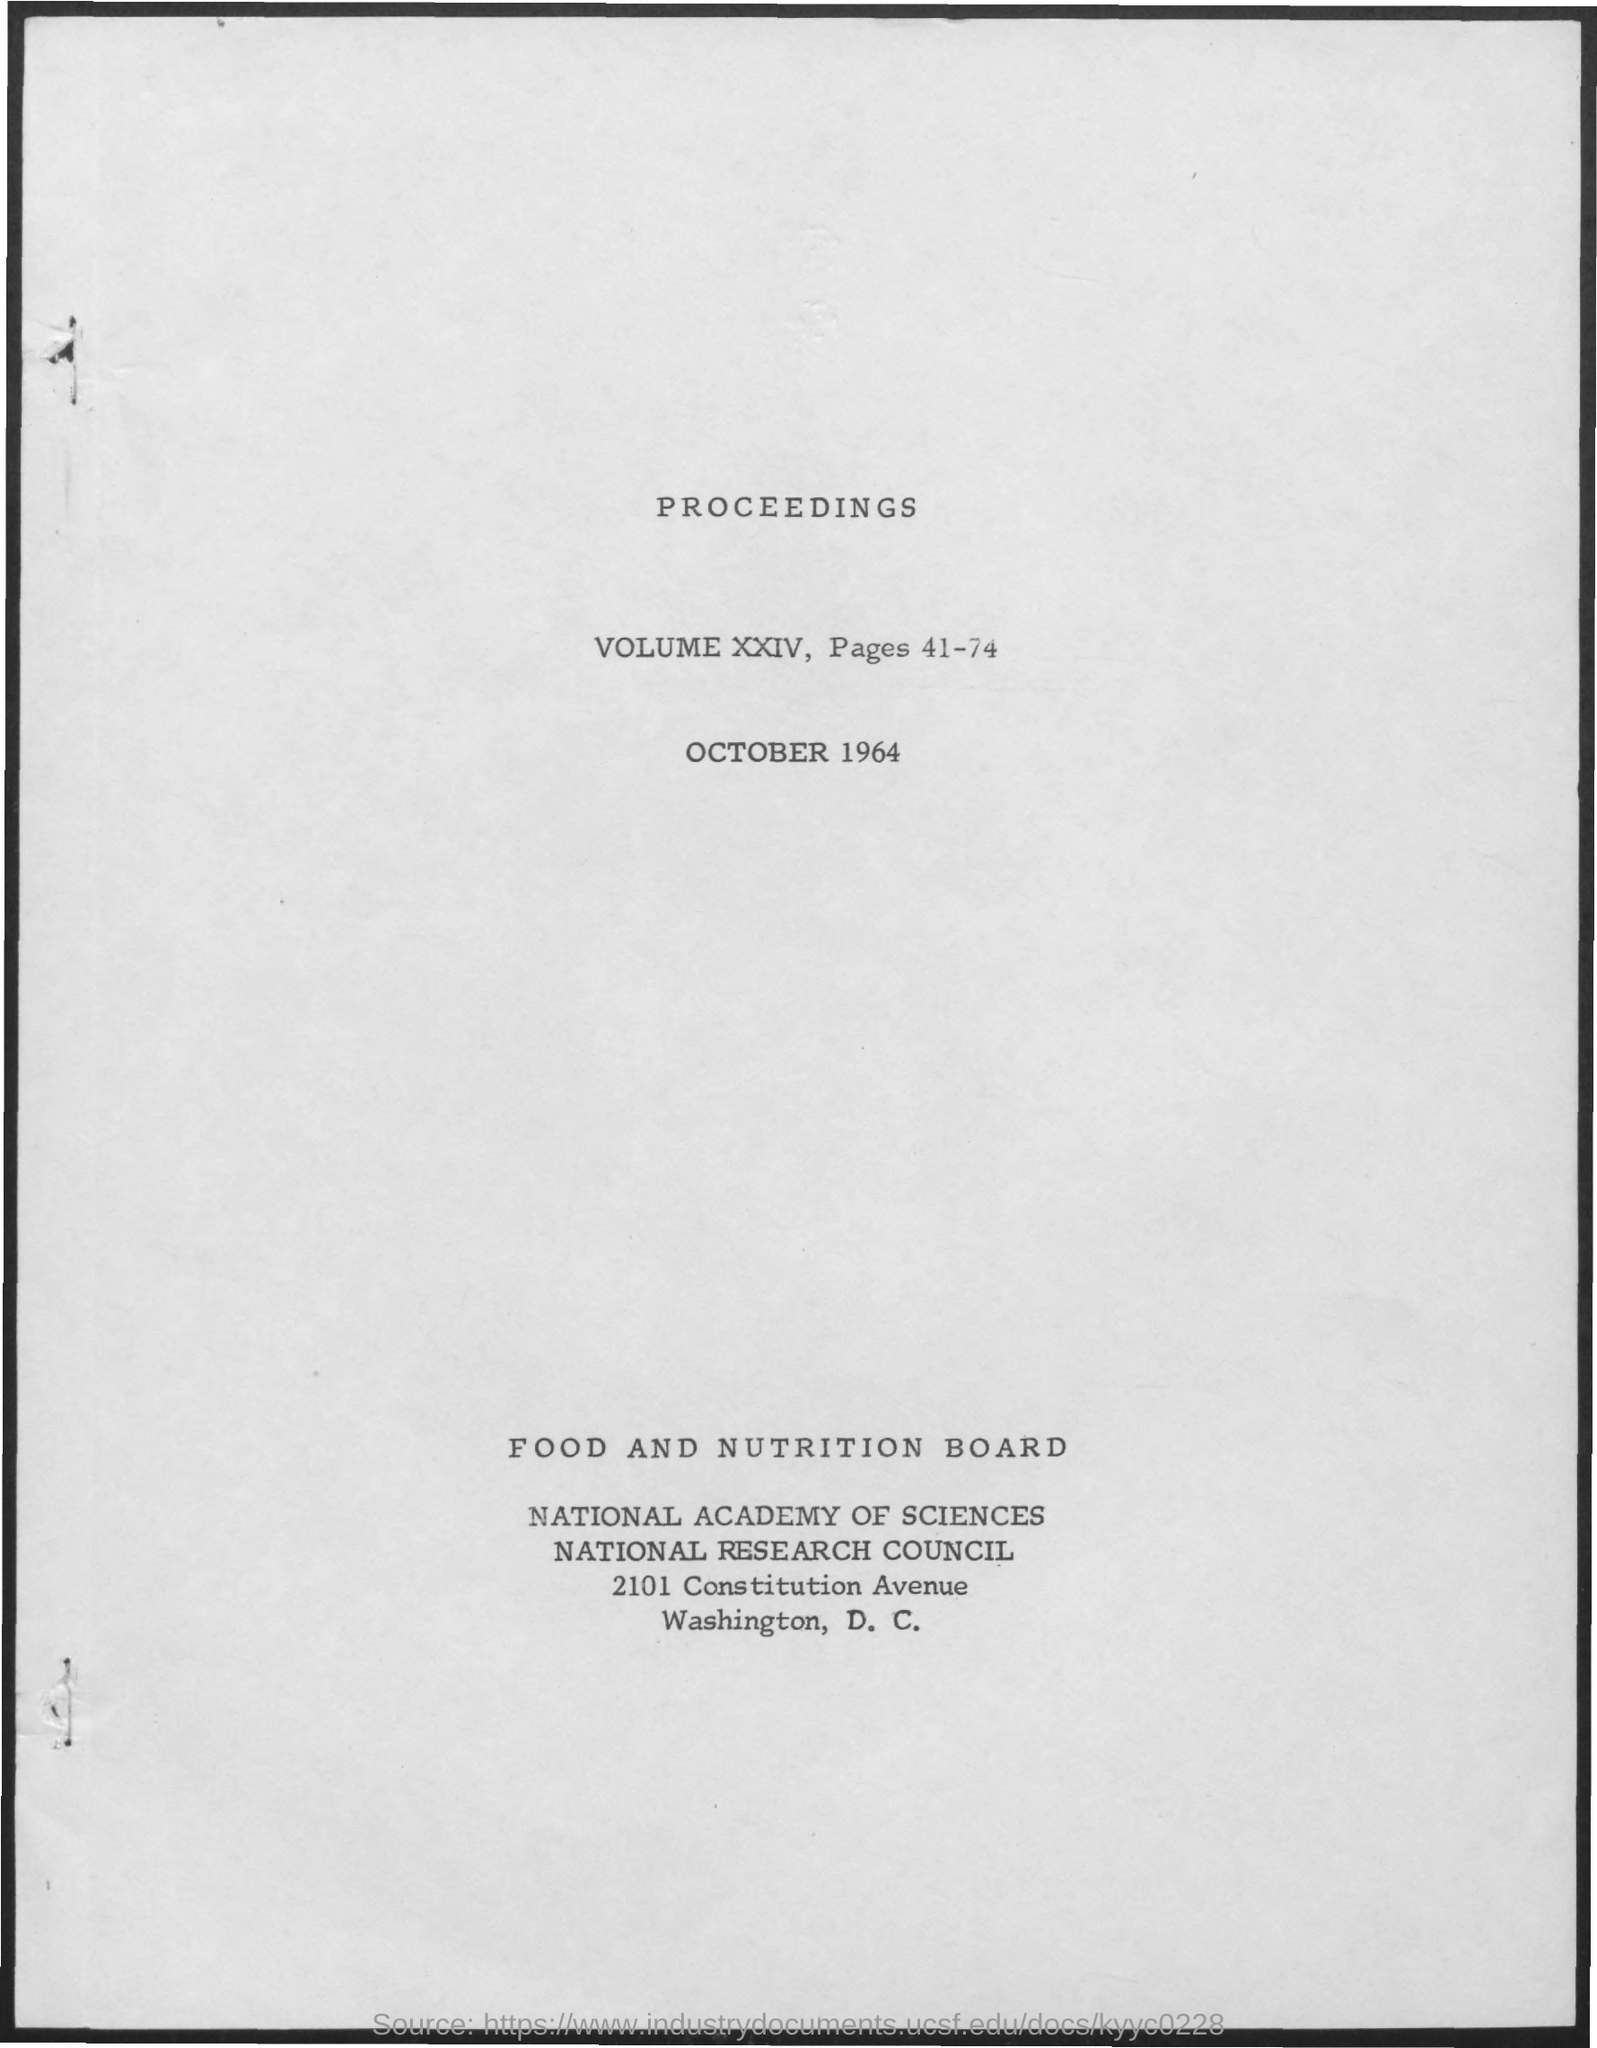What is the volume no of the proceedings?
Give a very brief answer. VOLUME XXIV. What is the page no of the proceedings?
Keep it short and to the point. 41-74. 